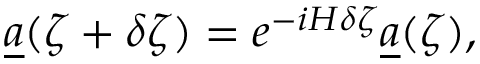Convert formula to latex. <formula><loc_0><loc_0><loc_500><loc_500>\underline { a } ( \zeta + \delta \zeta ) = e ^ { - i H \delta \zeta } \underline { a } ( \zeta ) ,</formula> 